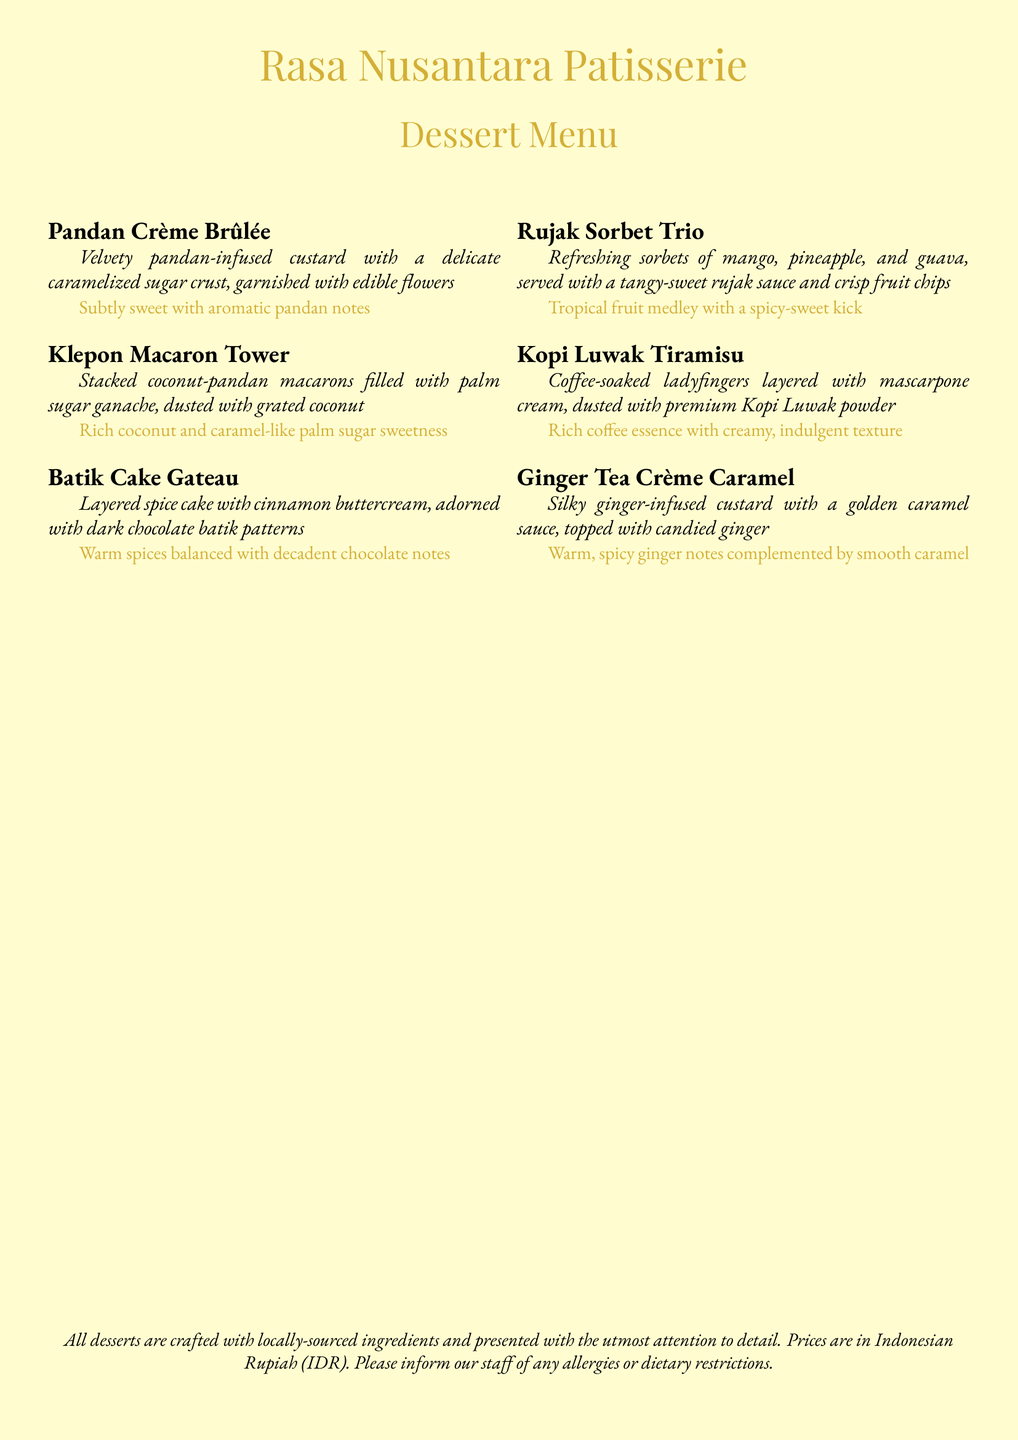What is the name of the dessert patisserie? The name of the patisserie is prominently displayed at the top of the menu.
Answer: Rasa Nusantara Patisserie How many types of dessert are listed in the menu? The number of dessert items can be counted from the list provided in the document.
Answer: Six What is the primary flavor of the Pandan Crème Brûlée? The description of the dessert mentions its flavor profile clearly.
Answer: Aromatic pandan notes Which dessert features a tropical fruit medley? The description of the dessert indicates it consists of tropical fruits.
Answer: Rujak Sorbet Trio What ingredient is used to infuse the Ginger Tea Crème Caramel? The specific flavoring ingredient is mentioned in the dessert's description.
Answer: Ginger Which dessert has a dark chocolate motif on it? The characteristic of the dessert is described in relation to its appearance.
Answer: Batik Cake Gateau 